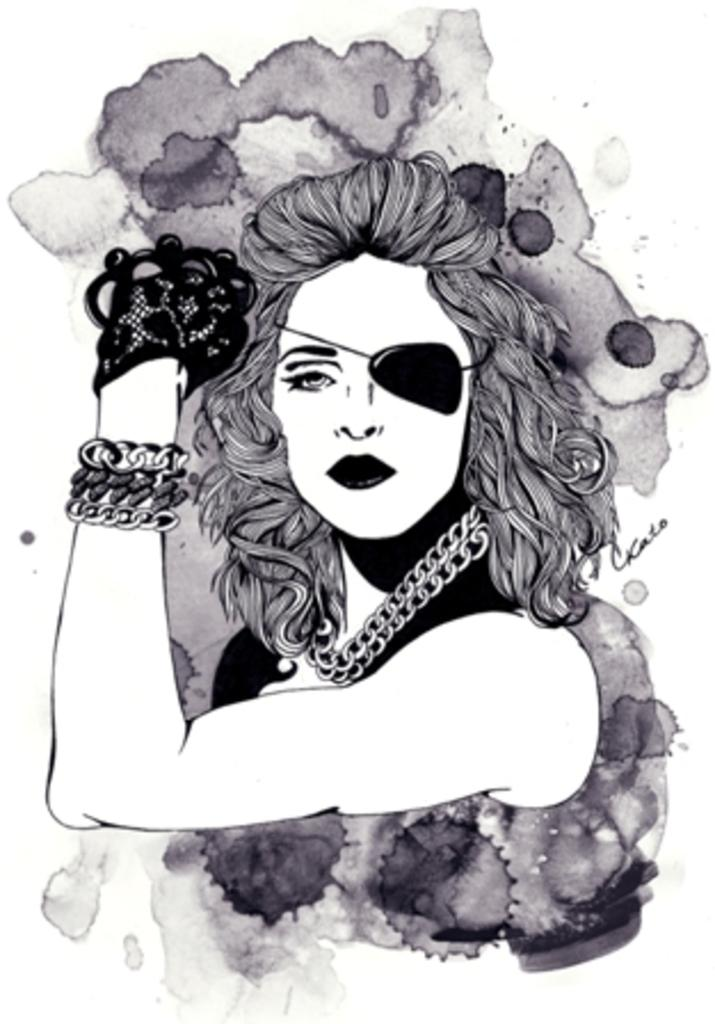What is depicted in the image? There is a drawing of a woman in the image. Can you describe the woman in the drawing? The woman in the drawing has an eye-patch. What type of berry is the woman holding in the drawing? There is no berry present in the drawing; the woman has an eye-patch. 